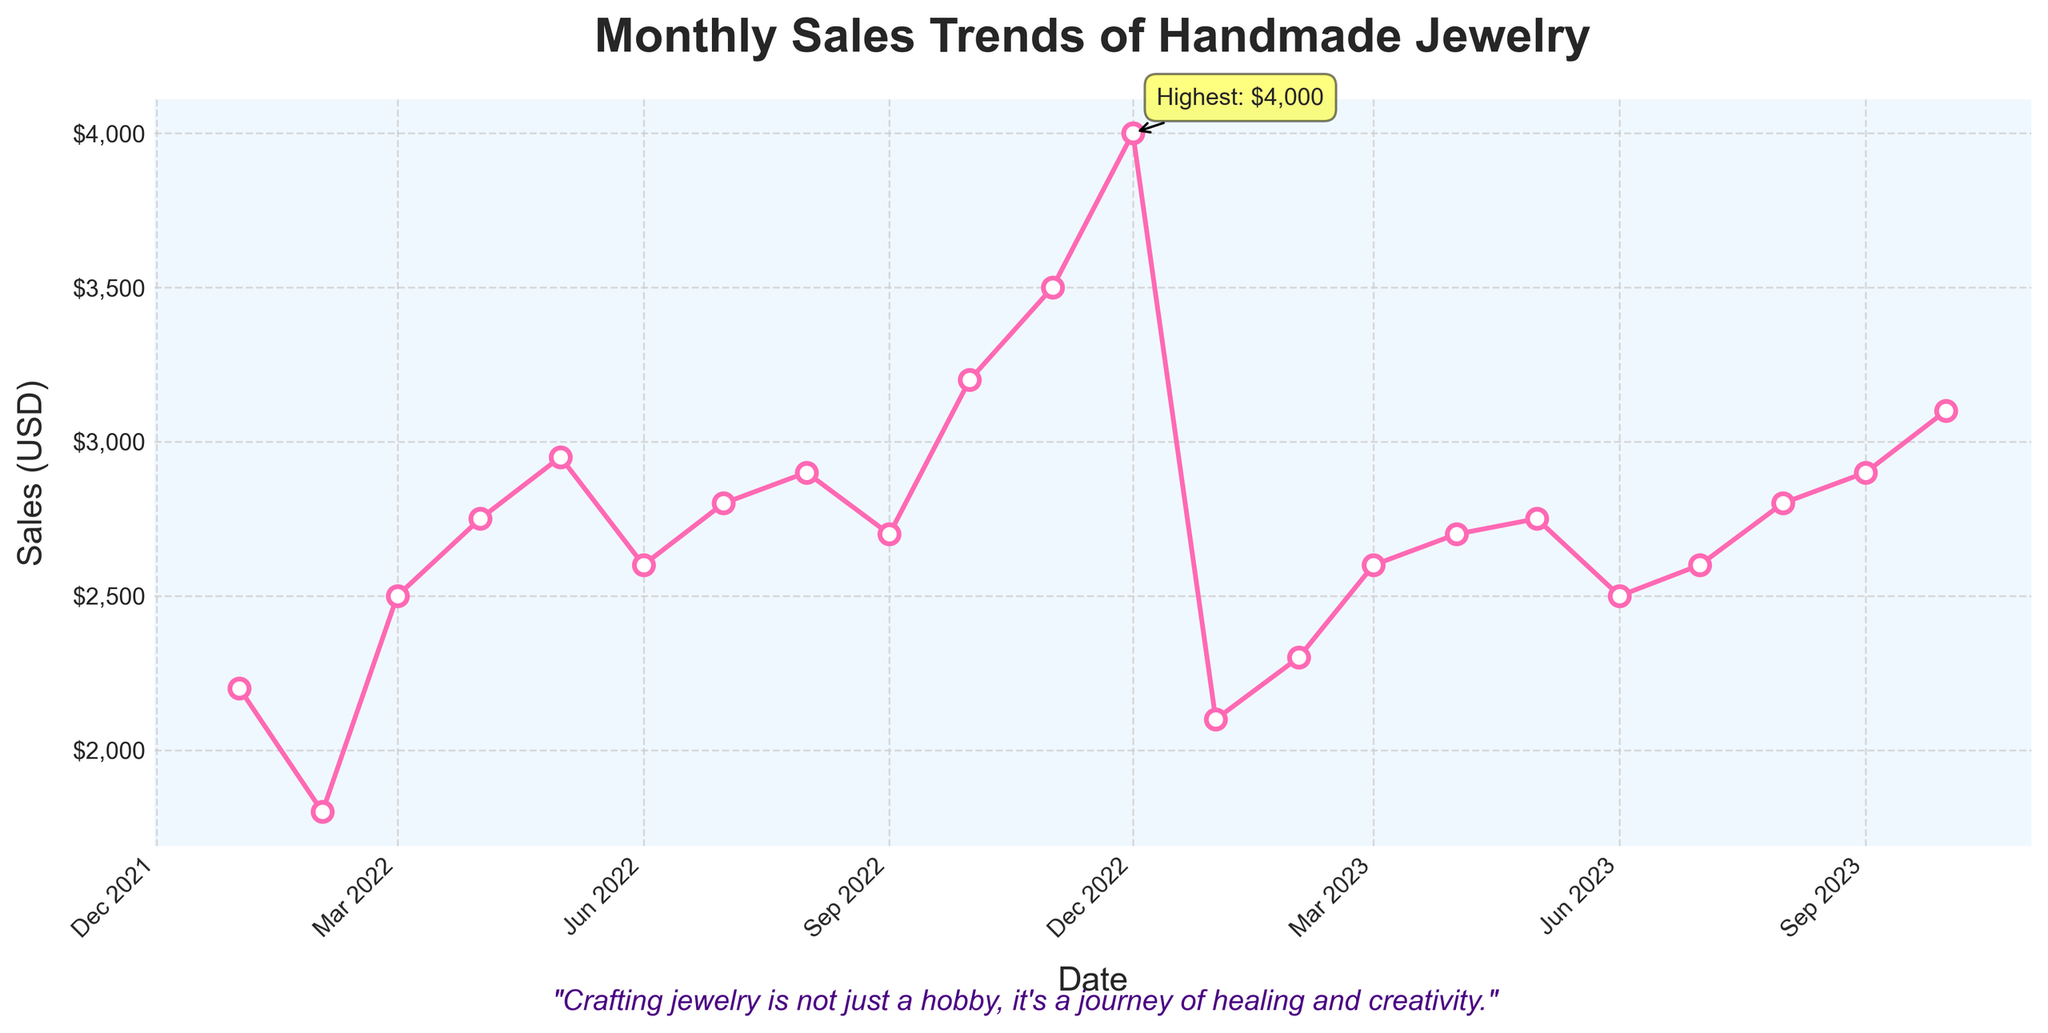What is the title of the plot? The title is displayed at the top of the plot. It reads "Monthly Sales Trends of Handmade Jewelry".
Answer: Monthly Sales Trends of Handmade Jewelry How many data points are shown in the plot? The plot shows monthly data spanning from January 2022 to October 2023. Counting each month in the timeline gives us 22 data points.
Answer: 22 What is the highest sales value recorded and in which month? The highest sales value can be identified by looking at the peak point on the plot. The annotation points to December 2022 with a value of $4000.
Answer: $4000 in December 2022 How did the sales trend differ between January 2022 and January 2023? To compare, identify both points: January 2022 shows $2200 and January 2023 shows $2100. There is a decrease.
Answer: Decreased by $100 When did the sales first surpass $3000? Look for the first data point where the y-axis value exceeds $3000. It appears in October 2022, with a sales value of $3200.
Answer: October 2022 What has been the general trend of sales from May 2023 to October 2023? Observe the data points from May 2023 ($2750) to October 2023 ($3100). Generally, there is an upward trend.
Answer: Upward trend What is the difference in sales between the highest and lowest months? The highest sales is $4000 in December 2022, and the lowest is $1800 in February 2022. Subtract the lowest value from the highest: $4000 - $1800 = $2200.
Answer: $2200 How do the sales in March 2023 compare to the sales in March 2022? Sales in March 2022 are $2500 and in March 2023 they are $2600. There is an increase in sales.
Answer: Increased by $100 What is the general color scheme of the plot? The line is pink, and the background has a subtle light blue hue. The markers have a white interior with visible outlines.
Answer: Pink line, light blue background, white markers 